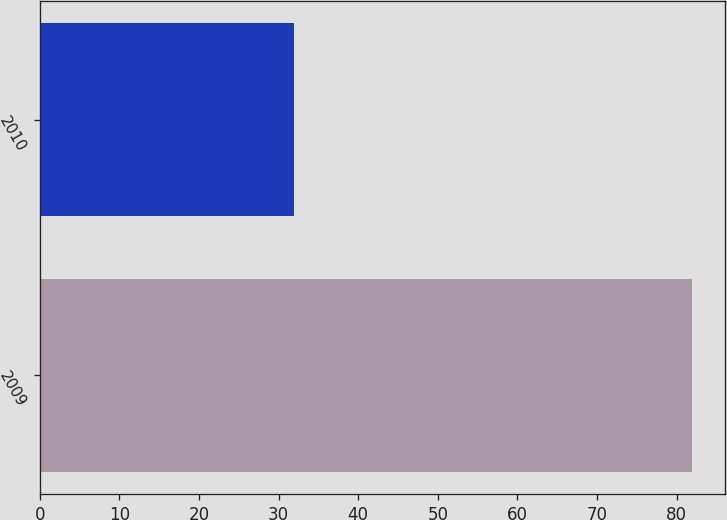Convert chart to OTSL. <chart><loc_0><loc_0><loc_500><loc_500><bar_chart><fcel>2009<fcel>2010<nl><fcel>82<fcel>32<nl></chart> 